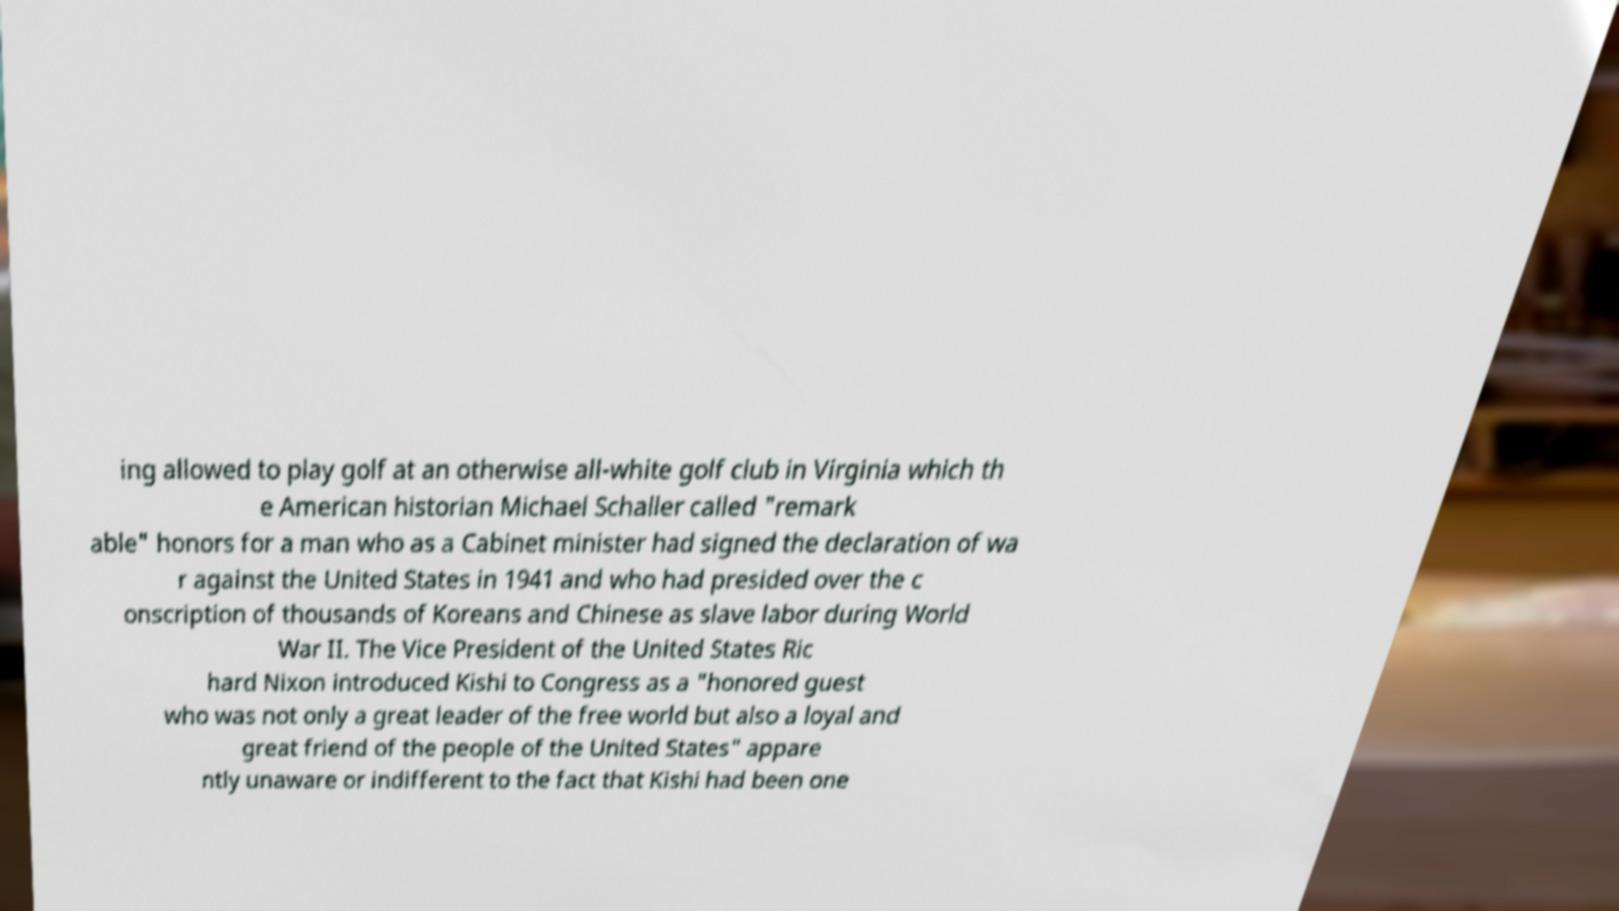Can you read and provide the text displayed in the image?This photo seems to have some interesting text. Can you extract and type it out for me? ing allowed to play golf at an otherwise all-white golf club in Virginia which th e American historian Michael Schaller called "remark able" honors for a man who as a Cabinet minister had signed the declaration of wa r against the United States in 1941 and who had presided over the c onscription of thousands of Koreans and Chinese as slave labor during World War II. The Vice President of the United States Ric hard Nixon introduced Kishi to Congress as a "honored guest who was not only a great leader of the free world but also a loyal and great friend of the people of the United States" appare ntly unaware or indifferent to the fact that Kishi had been one 